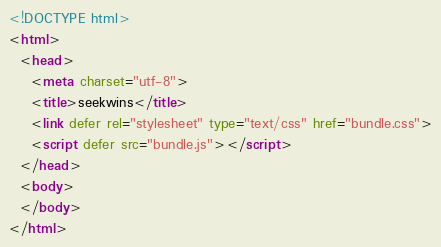Convert code to text. <code><loc_0><loc_0><loc_500><loc_500><_HTML_><!DOCTYPE html>
<html>
  <head>
    <meta charset="utf-8">
    <title>seekwins</title>
    <link defer rel="stylesheet" type="text/css" href="bundle.css">
    <script defer src="bundle.js"></script>
  </head>
  <body>
  </body>
</html>
</code> 